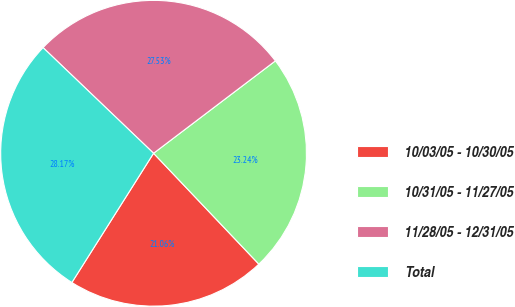Convert chart. <chart><loc_0><loc_0><loc_500><loc_500><pie_chart><fcel>10/03/05 - 10/30/05<fcel>10/31/05 - 11/27/05<fcel>11/28/05 - 12/31/05<fcel>Total<nl><fcel>21.06%<fcel>23.24%<fcel>27.53%<fcel>28.17%<nl></chart> 